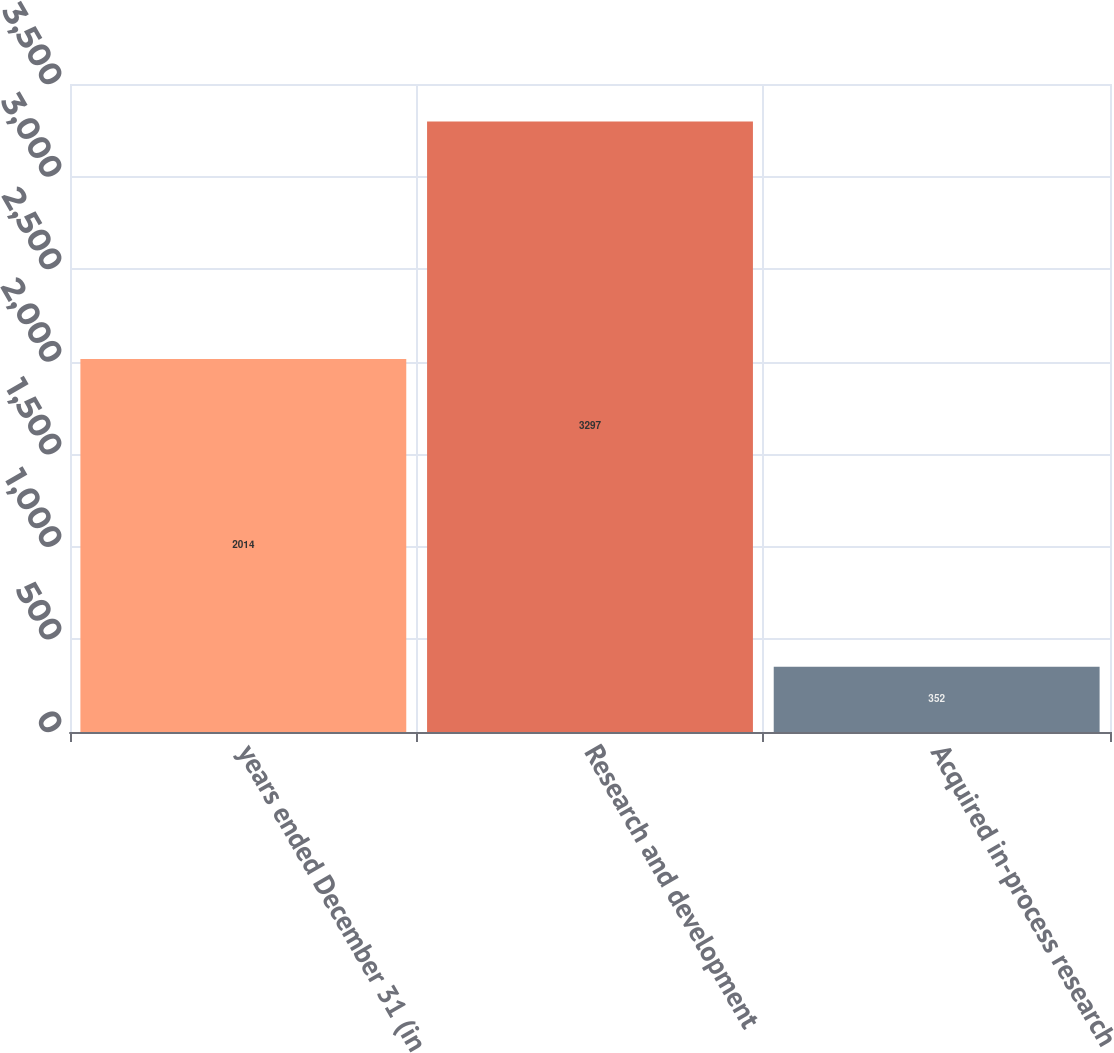Convert chart to OTSL. <chart><loc_0><loc_0><loc_500><loc_500><bar_chart><fcel>years ended December 31 (in<fcel>Research and development<fcel>Acquired in-process research<nl><fcel>2014<fcel>3297<fcel>352<nl></chart> 